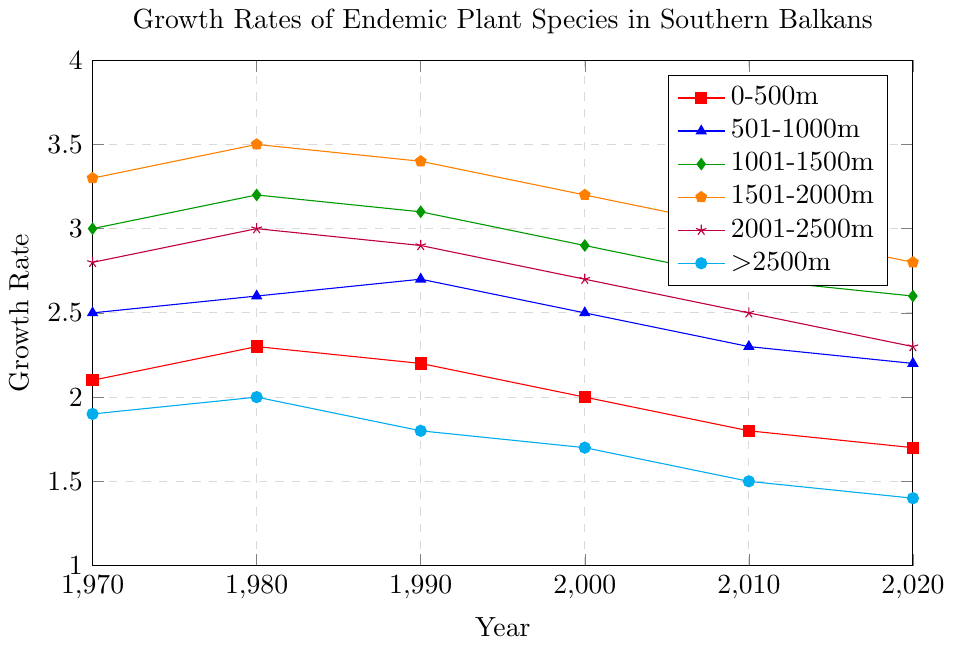What is the general trend in growth rates for the altitude range 0-500m from 1970 to 2020? The growth rate for the altitude range 0-500m starts at 2.1 in 1970 and decreases to 1.7 by 2020. Therefore, the general trend is a decrease over time.
Answer: Decreasing Which altitude range had the highest growth rate in 1980? In the year 1980, the altitude ranges had the following growth rates: 0-500m (2.3), 501-1000m (2.6), 1001-1500m (3.2), 1501-2000m (3.5), 2001-2500m (3.0), and >2500m (2.0). The highest growth rate is for the 1501-2000m range at 3.5.
Answer: 1501-2000m By how much did the growth rate change for the altitude range 2001-2500m from 1970 to 2020? The growth rate for 2001-2500m was 2.8 in 1970 and 2.3 in 2020. The change in growth rate is 2.8 - 2.3 = 0.5.
Answer: 0.5 What altitude range shows the least variation in growth rate from 1970 to 2020? Calculating the difference in growth rates for each range from 1970 to 2020:
0-500m: 2.1 - 1.7 = 0.4
501-1000m: 2.5 - 2.2 = 0.3
1001-1500m: 3.0 - 2.6 = 0.4
1501-2000m: 3.3 - 2.8 = 0.5
2001-2500m: 2.8 - 2.3 = 0.5
>2500m: 1.9 - 1.4 = 0.5
The smallest difference is 0.3 for the range 501-1000m.
Answer: 501-1000m Which altitude range had the highest growth rate in 2020, and what was that value? In the year 2020, the growth rates for the altitude ranges are: 0-500m (1.7), 501-1000m (2.2), 1001-1500m (2.6), 1501-2000m (2.8), 2001-2500m (2.3), and >2500m (1.4). The highest growth rate is for the 1501-2000m range at 2.8.
Answer: 1501-2000m, 2.8 In which decade did the altitude range 1001-1500m experience its highest growth rate? The altitude range 1001-1500m had growth rates of 3.0 in 1970, 3.2 in 1980, 3.1 in 1990, 2.9 in 2000, 2.7 in 2010, and 2.6 in 2020. The highest growth rate occurred in 1980 (3.2).
Answer: 1980 Which altitude range saw the most significant decrease in growth rate from 1980 to 2020? Calculating the difference in growth rates from 1980 to 2020 for each range:
0-500m: 2.3 - 1.7 = 0.6
501-1000m: 2.6 - 2.2 = 0.4
1001-1500m: 3.2 - 2.6 = 0.6
1501-2000m: 3.5 - 2.8 = 0.7
2001-2500m: 3.0 - 2.3 = 0.7
>2500m: 2.0 - 1.4 = 0.6
Both 1501-2000m and 2001-2500m saw the largest decrease of 0.7.
Answer: 1501-2000m and 2001-2500m What was the average growth rate in the 1990s for all altitude ranges combined? The average growth rate for the 1990s is calculated by taking the sum of the growth rates for each altitude range in that decade and dividing by the number of ranges: (2.2 + 2.7 + 3.1 + 3.4 + 2.9 + 1.8)/6 = 16.1/6 ≈ 2.68.
Answer: 2.68 